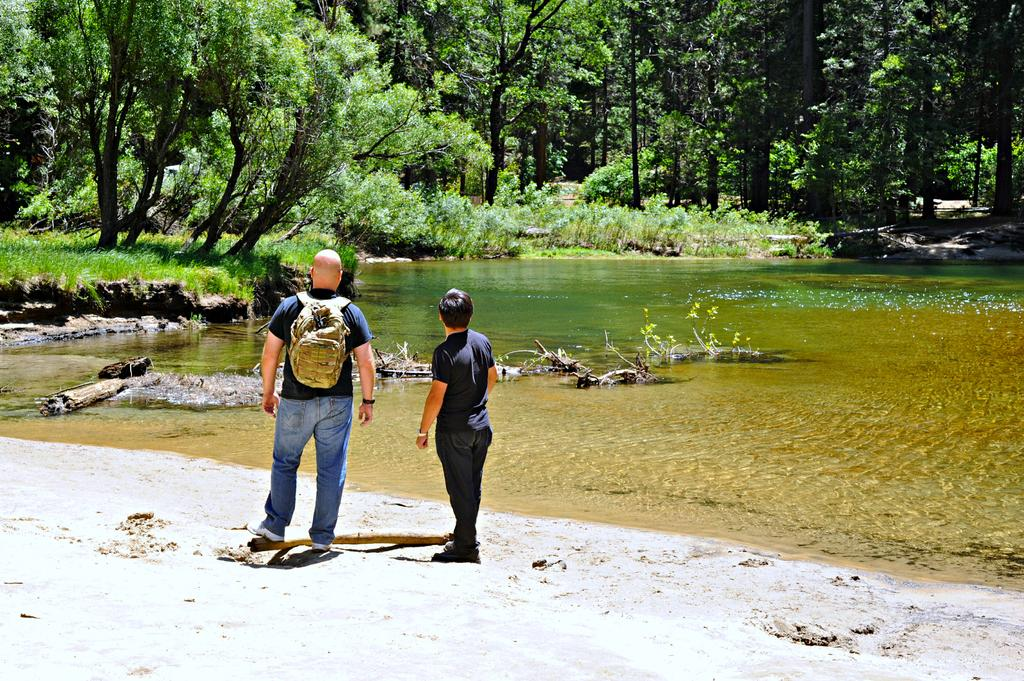What is the setting of the image? The image depicts a river bank. How many people are in the image? There are two men standing on the bank. What is the first man wearing? The first man is wearing a bag. What can be seen in the background of the image? There is grass and many trees in the background. What color of paint is being used by the goat in the image? There is no goat present in the image, and therefore no paint or painting activity can be observed. 